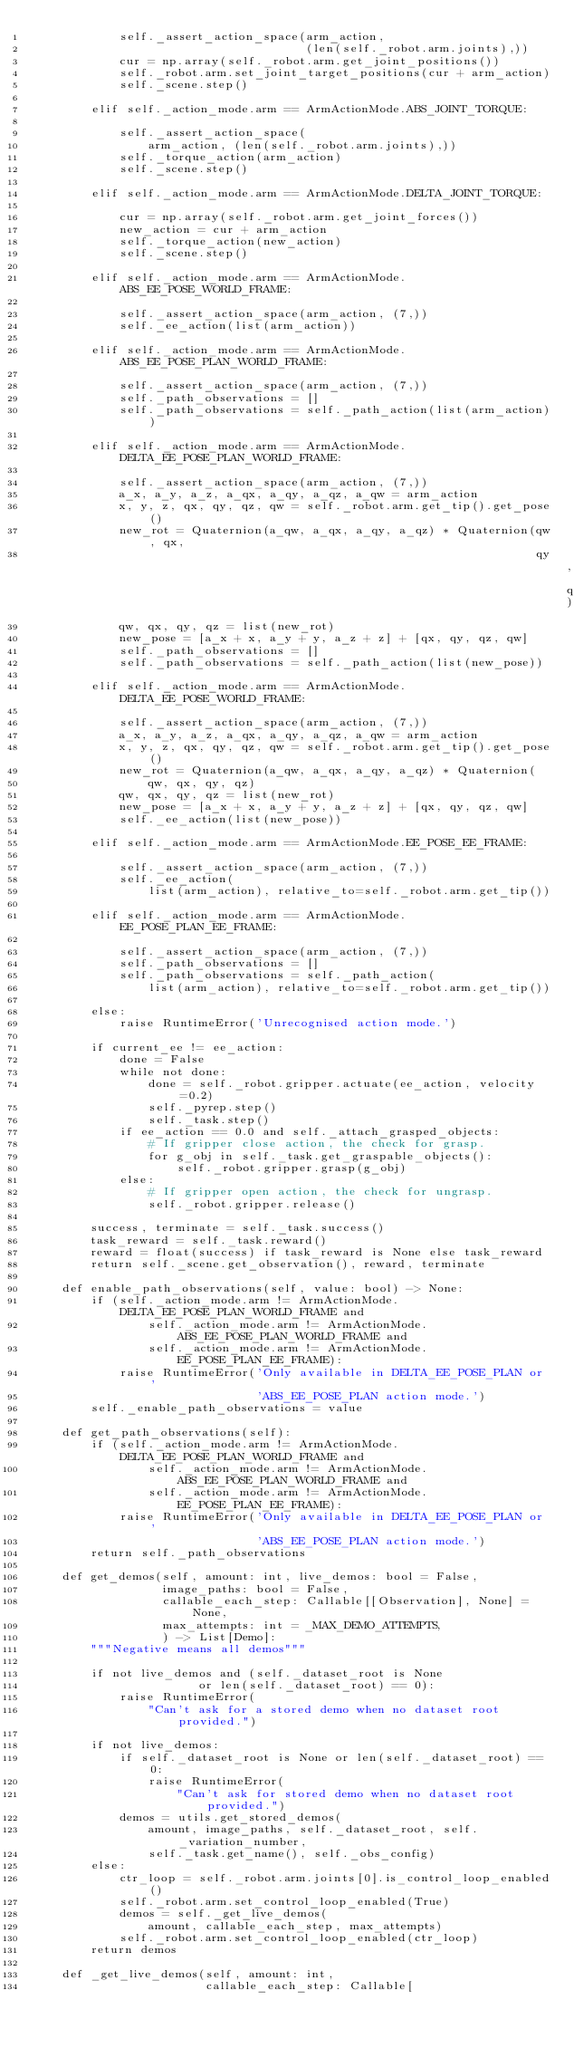Convert code to text. <code><loc_0><loc_0><loc_500><loc_500><_Python_>            self._assert_action_space(arm_action,
                                      (len(self._robot.arm.joints),))
            cur = np.array(self._robot.arm.get_joint_positions())
            self._robot.arm.set_joint_target_positions(cur + arm_action)
            self._scene.step()

        elif self._action_mode.arm == ArmActionMode.ABS_JOINT_TORQUE:

            self._assert_action_space(
                arm_action, (len(self._robot.arm.joints),))
            self._torque_action(arm_action)
            self._scene.step()

        elif self._action_mode.arm == ArmActionMode.DELTA_JOINT_TORQUE:

            cur = np.array(self._robot.arm.get_joint_forces())
            new_action = cur + arm_action
            self._torque_action(new_action)
            self._scene.step()

        elif self._action_mode.arm == ArmActionMode.ABS_EE_POSE_WORLD_FRAME:

            self._assert_action_space(arm_action, (7,))
            self._ee_action(list(arm_action))

        elif self._action_mode.arm == ArmActionMode.ABS_EE_POSE_PLAN_WORLD_FRAME:

            self._assert_action_space(arm_action, (7,))
            self._path_observations = []
            self._path_observations = self._path_action(list(arm_action))

        elif self._action_mode.arm == ArmActionMode.DELTA_EE_POSE_PLAN_WORLD_FRAME:

            self._assert_action_space(arm_action, (7,))
            a_x, a_y, a_z, a_qx, a_qy, a_qz, a_qw = arm_action
            x, y, z, qx, qy, qz, qw = self._robot.arm.get_tip().get_pose()
            new_rot = Quaternion(a_qw, a_qx, a_qy, a_qz) * Quaternion(qw, qx,
                                                                      qy, qz)
            qw, qx, qy, qz = list(new_rot)
            new_pose = [a_x + x, a_y + y, a_z + z] + [qx, qy, qz, qw]
            self._path_observations = []
            self._path_observations = self._path_action(list(new_pose))

        elif self._action_mode.arm == ArmActionMode.DELTA_EE_POSE_WORLD_FRAME:

            self._assert_action_space(arm_action, (7,))
            a_x, a_y, a_z, a_qx, a_qy, a_qz, a_qw = arm_action
            x, y, z, qx, qy, qz, qw = self._robot.arm.get_tip().get_pose()
            new_rot = Quaternion(a_qw, a_qx, a_qy, a_qz) * Quaternion(
                qw, qx, qy, qz)
            qw, qx, qy, qz = list(new_rot)
            new_pose = [a_x + x, a_y + y, a_z + z] + [qx, qy, qz, qw]
            self._ee_action(list(new_pose))

        elif self._action_mode.arm == ArmActionMode.EE_POSE_EE_FRAME:

            self._assert_action_space(arm_action, (7,))
            self._ee_action(
                list(arm_action), relative_to=self._robot.arm.get_tip())

        elif self._action_mode.arm == ArmActionMode.EE_POSE_PLAN_EE_FRAME:

            self._assert_action_space(arm_action, (7,))
            self._path_observations = []
            self._path_observations = self._path_action(
                list(arm_action), relative_to=self._robot.arm.get_tip())

        else:
            raise RuntimeError('Unrecognised action mode.')

        if current_ee != ee_action:
            done = False
            while not done:
                done = self._robot.gripper.actuate(ee_action, velocity=0.2)
                self._pyrep.step()
                self._task.step()
            if ee_action == 0.0 and self._attach_grasped_objects:
                # If gripper close action, the check for grasp.
                for g_obj in self._task.get_graspable_objects():
                    self._robot.gripper.grasp(g_obj)
            else:
                # If gripper open action, the check for ungrasp.
                self._robot.gripper.release()

        success, terminate = self._task.success()
        task_reward = self._task.reward()
        reward = float(success) if task_reward is None else task_reward
        return self._scene.get_observation(), reward, terminate

    def enable_path_observations(self, value: bool) -> None:
        if (self._action_mode.arm != ArmActionMode.DELTA_EE_POSE_PLAN_WORLD_FRAME and
                self._action_mode.arm != ArmActionMode.ABS_EE_POSE_PLAN_WORLD_FRAME and
                self._action_mode.arm != ArmActionMode.EE_POSE_PLAN_EE_FRAME):
            raise RuntimeError('Only available in DELTA_EE_POSE_PLAN or '
                               'ABS_EE_POSE_PLAN action mode.')
        self._enable_path_observations = value

    def get_path_observations(self):
        if (self._action_mode.arm != ArmActionMode.DELTA_EE_POSE_PLAN_WORLD_FRAME and
                self._action_mode.arm != ArmActionMode.ABS_EE_POSE_PLAN_WORLD_FRAME and
                self._action_mode.arm != ArmActionMode.EE_POSE_PLAN_EE_FRAME):
            raise RuntimeError('Only available in DELTA_EE_POSE_PLAN or '
                               'ABS_EE_POSE_PLAN action mode.')
        return self._path_observations

    def get_demos(self, amount: int, live_demos: bool = False,
                  image_paths: bool = False,
                  callable_each_step: Callable[[Observation], None] = None,
                  max_attempts: int = _MAX_DEMO_ATTEMPTS,
                  ) -> List[Demo]:
        """Negative means all demos"""

        if not live_demos and (self._dataset_root is None
                       or len(self._dataset_root) == 0):
            raise RuntimeError(
                "Can't ask for a stored demo when no dataset root provided.")

        if not live_demos:
            if self._dataset_root is None or len(self._dataset_root) == 0:
                raise RuntimeError(
                    "Can't ask for stored demo when no dataset root provided.")
            demos = utils.get_stored_demos(
                amount, image_paths, self._dataset_root, self._variation_number,
                self._task.get_name(), self._obs_config)
        else:
            ctr_loop = self._robot.arm.joints[0].is_control_loop_enabled()
            self._robot.arm.set_control_loop_enabled(True)
            demos = self._get_live_demos(
                amount, callable_each_step, max_attempts)
            self._robot.arm.set_control_loop_enabled(ctr_loop)
        return demos

    def _get_live_demos(self, amount: int,
                        callable_each_step: Callable[</code> 